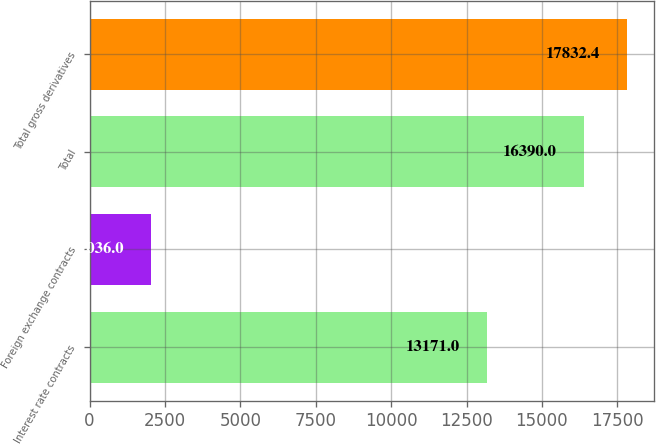<chart> <loc_0><loc_0><loc_500><loc_500><bar_chart><fcel>Interest rate contracts<fcel>Foreign exchange contracts<fcel>Total<fcel>Total gross derivatives<nl><fcel>13171<fcel>2036<fcel>16390<fcel>17832.4<nl></chart> 